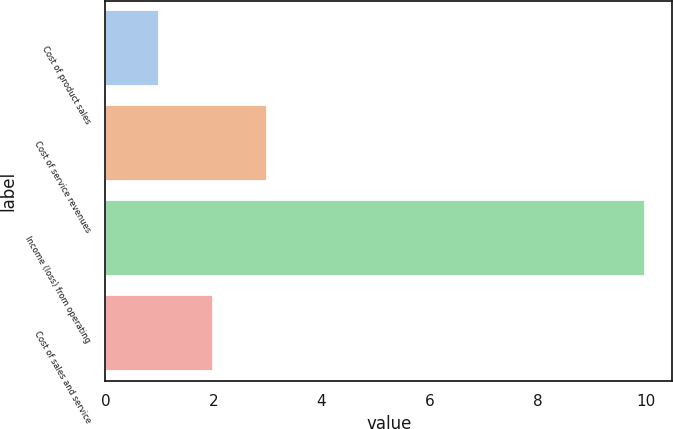<chart> <loc_0><loc_0><loc_500><loc_500><bar_chart><fcel>Cost of product sales<fcel>Cost of service revenues<fcel>Income (loss) from operating<fcel>Cost of sales and service<nl><fcel>1<fcel>3<fcel>10<fcel>2<nl></chart> 